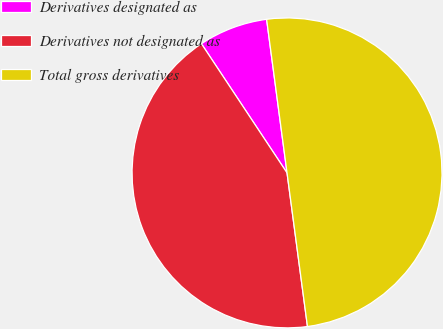Convert chart to OTSL. <chart><loc_0><loc_0><loc_500><loc_500><pie_chart><fcel>Derivatives designated as<fcel>Derivatives not designated as<fcel>Total gross derivatives<nl><fcel>7.21%<fcel>42.79%<fcel>50.0%<nl></chart> 